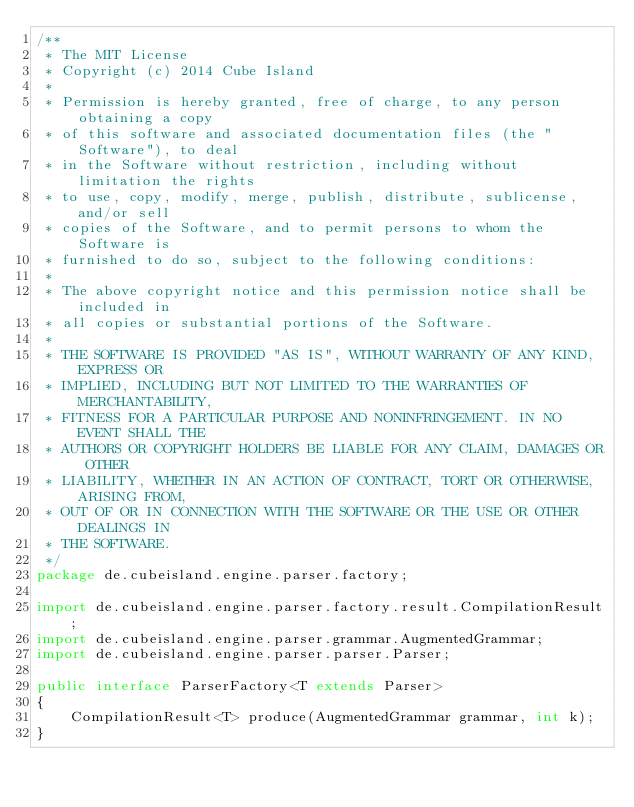<code> <loc_0><loc_0><loc_500><loc_500><_Java_>/**
 * The MIT License
 * Copyright (c) 2014 Cube Island
 *
 * Permission is hereby granted, free of charge, to any person obtaining a copy
 * of this software and associated documentation files (the "Software"), to deal
 * in the Software without restriction, including without limitation the rights
 * to use, copy, modify, merge, publish, distribute, sublicense, and/or sell
 * copies of the Software, and to permit persons to whom the Software is
 * furnished to do so, subject to the following conditions:
 *
 * The above copyright notice and this permission notice shall be included in
 * all copies or substantial portions of the Software.
 *
 * THE SOFTWARE IS PROVIDED "AS IS", WITHOUT WARRANTY OF ANY KIND, EXPRESS OR
 * IMPLIED, INCLUDING BUT NOT LIMITED TO THE WARRANTIES OF MERCHANTABILITY,
 * FITNESS FOR A PARTICULAR PURPOSE AND NONINFRINGEMENT. IN NO EVENT SHALL THE
 * AUTHORS OR COPYRIGHT HOLDERS BE LIABLE FOR ANY CLAIM, DAMAGES OR OTHER
 * LIABILITY, WHETHER IN AN ACTION OF CONTRACT, TORT OR OTHERWISE, ARISING FROM,
 * OUT OF OR IN CONNECTION WITH THE SOFTWARE OR THE USE OR OTHER DEALINGS IN
 * THE SOFTWARE.
 */
package de.cubeisland.engine.parser.factory;

import de.cubeisland.engine.parser.factory.result.CompilationResult;
import de.cubeisland.engine.parser.grammar.AugmentedGrammar;
import de.cubeisland.engine.parser.parser.Parser;

public interface ParserFactory<T extends Parser>
{
    CompilationResult<T> produce(AugmentedGrammar grammar, int k);
}
</code> 